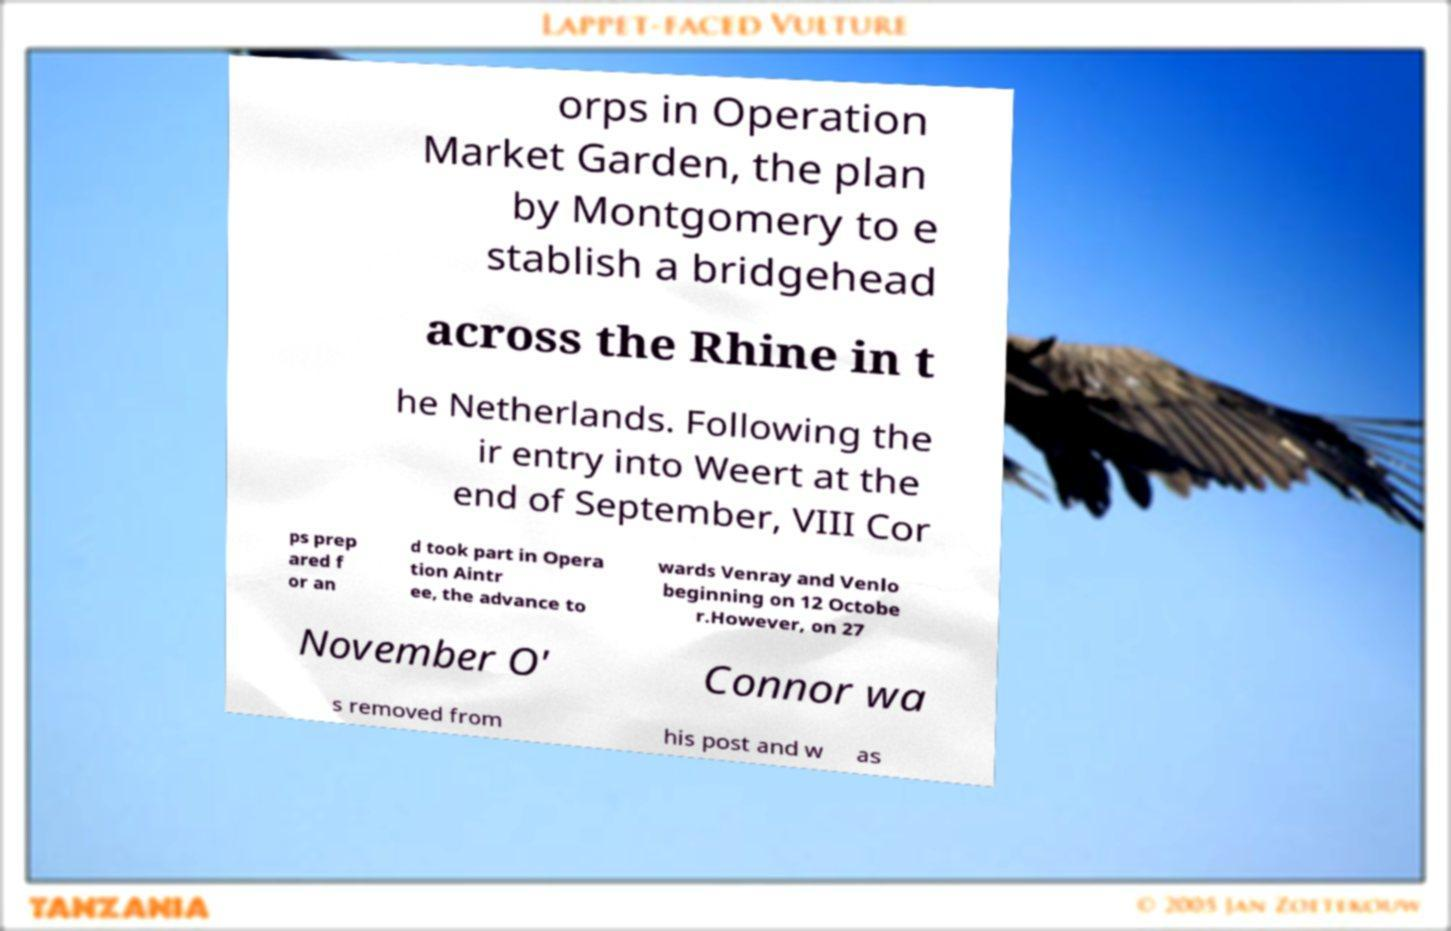Can you read and provide the text displayed in the image?This photo seems to have some interesting text. Can you extract and type it out for me? orps in Operation Market Garden, the plan by Montgomery to e stablish a bridgehead across the Rhine in t he Netherlands. Following the ir entry into Weert at the end of September, VIII Cor ps prep ared f or an d took part in Opera tion Aintr ee, the advance to wards Venray and Venlo beginning on 12 Octobe r.However, on 27 November O' Connor wa s removed from his post and w as 